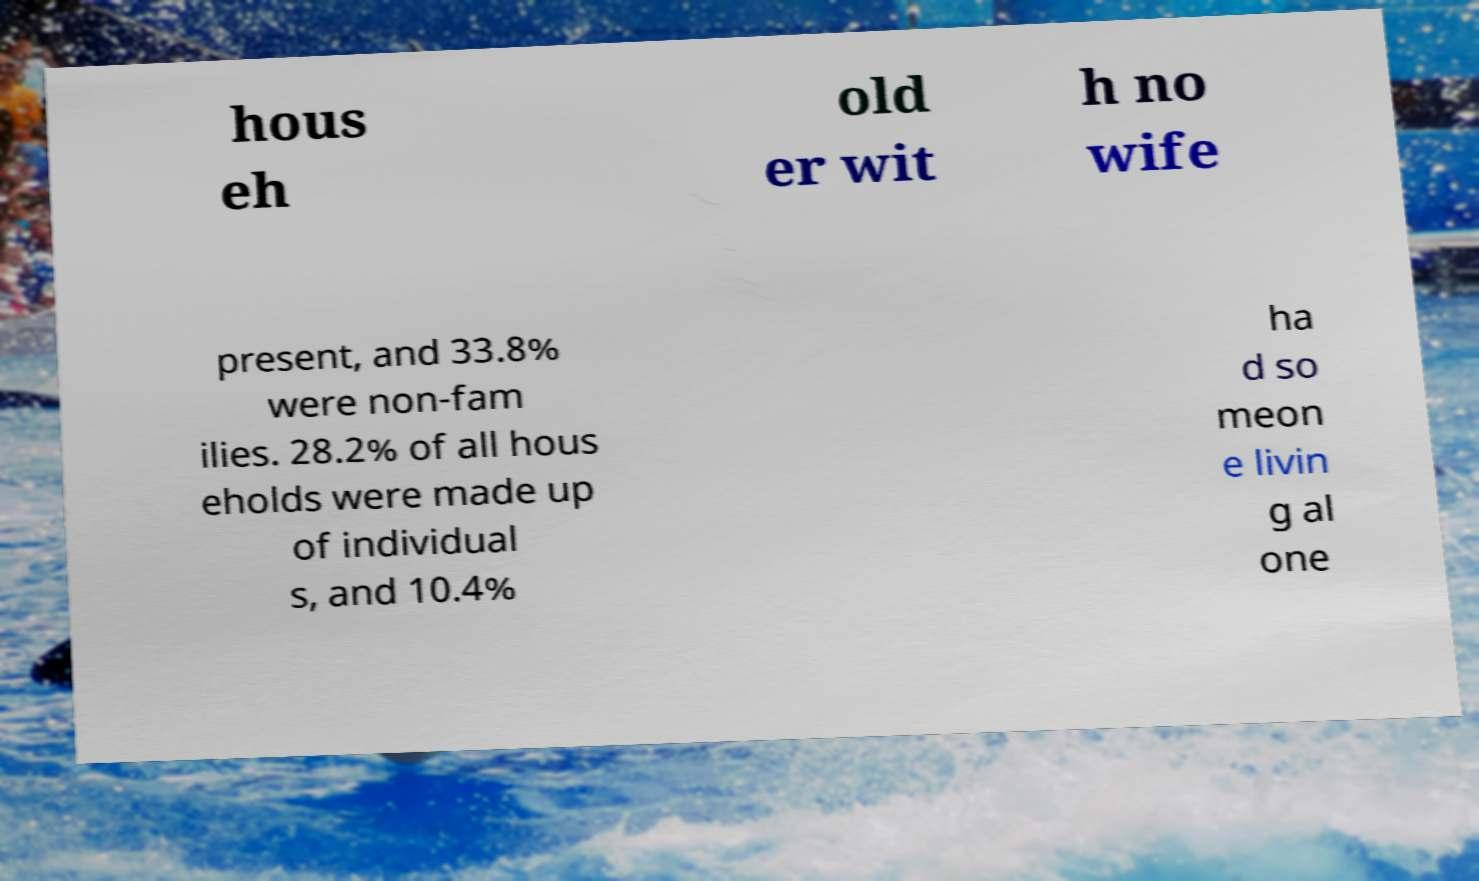Could you extract and type out the text from this image? hous eh old er wit h no wife present, and 33.8% were non-fam ilies. 28.2% of all hous eholds were made up of individual s, and 10.4% ha d so meon e livin g al one 